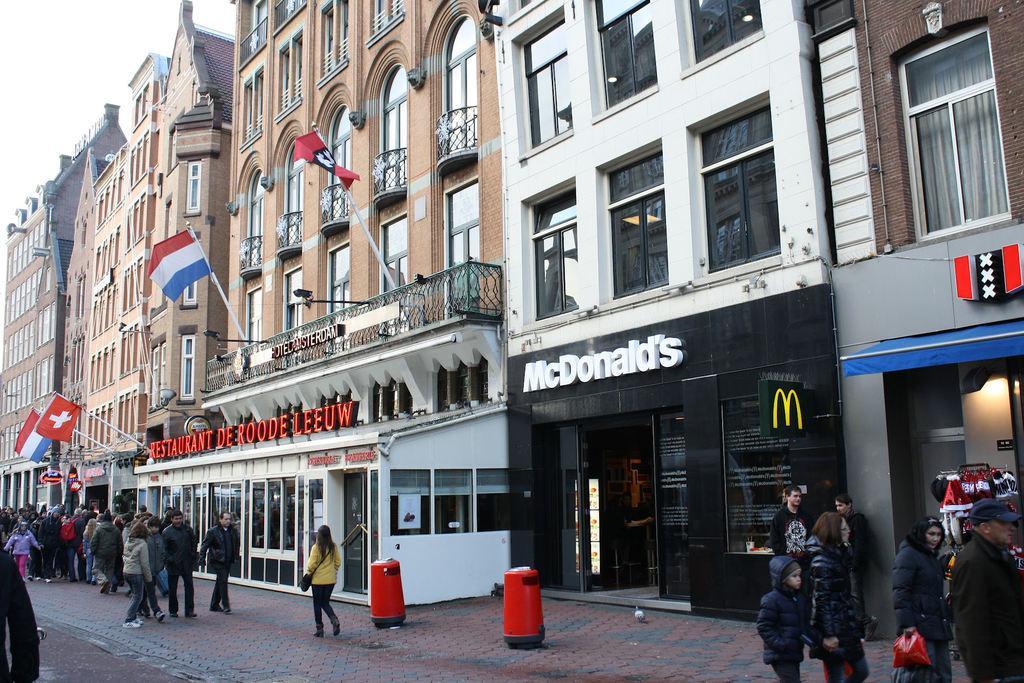Could you give a brief overview of what you see in this image? In this image there are people walking on a footpath and there are dustbins, in the background there are buildings, for that buildings there are windows, flags and there is some text. 